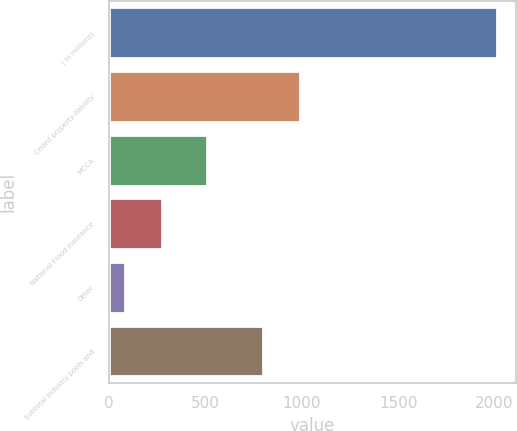<chart> <loc_0><loc_0><loc_500><loc_500><bar_chart><fcel>( in millions)<fcel>Ceded property-liability<fcel>MCCA<fcel>National Flood Insurance<fcel>Other<fcel>Subtotal industry pools and<nl><fcel>2011<fcel>989.7<fcel>509<fcel>276.7<fcel>84<fcel>797<nl></chart> 